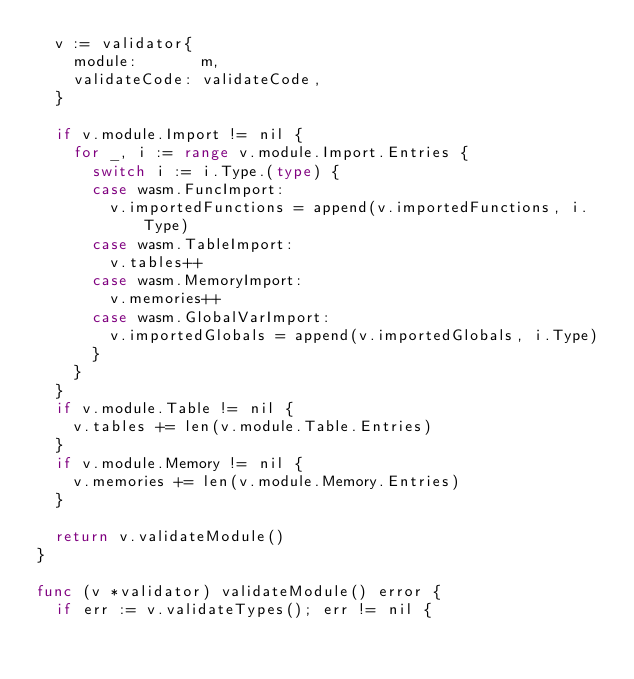Convert code to text. <code><loc_0><loc_0><loc_500><loc_500><_Go_>	v := validator{
		module:       m,
		validateCode: validateCode,
	}

	if v.module.Import != nil {
		for _, i := range v.module.Import.Entries {
			switch i := i.Type.(type) {
			case wasm.FuncImport:
				v.importedFunctions = append(v.importedFunctions, i.Type)
			case wasm.TableImport:
				v.tables++
			case wasm.MemoryImport:
				v.memories++
			case wasm.GlobalVarImport:
				v.importedGlobals = append(v.importedGlobals, i.Type)
			}
		}
	}
	if v.module.Table != nil {
		v.tables += len(v.module.Table.Entries)
	}
	if v.module.Memory != nil {
		v.memories += len(v.module.Memory.Entries)
	}

	return v.validateModule()
}

func (v *validator) validateModule() error {
	if err := v.validateTypes(); err != nil {</code> 